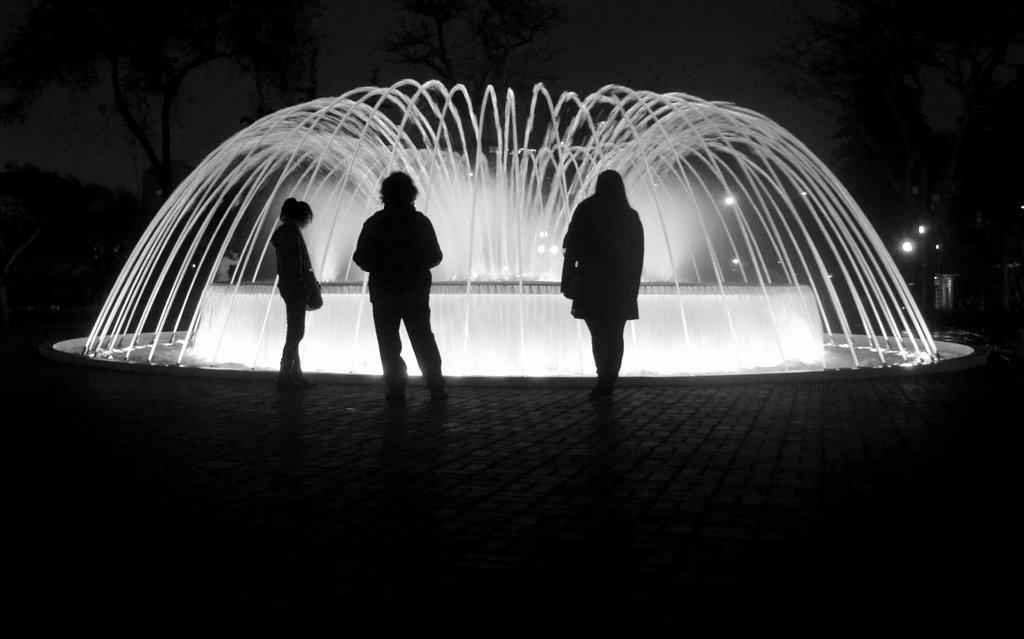Could you give a brief overview of what you see in this image? In the center of the image there are three persons on the floor. There is a fountain. In the background of the image there are trees and sky. 